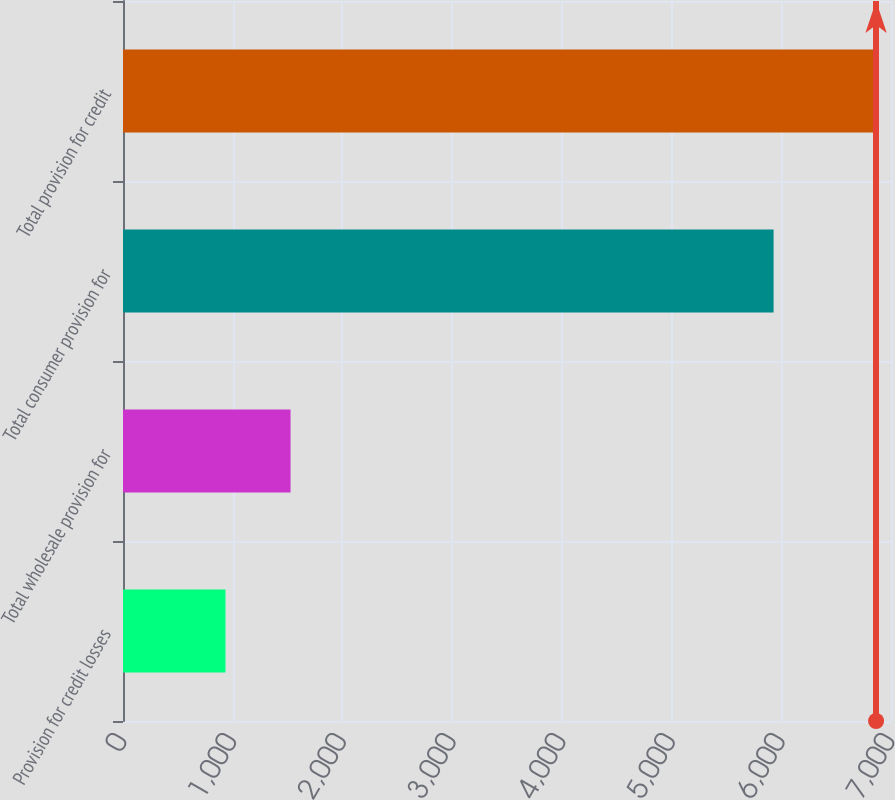Convert chart. <chart><loc_0><loc_0><loc_500><loc_500><bar_chart><fcel>Provision for credit losses<fcel>Total wholesale provision for<fcel>Total consumer provision for<fcel>Total provision for credit<nl><fcel>934<fcel>1527<fcel>5930<fcel>6864<nl></chart> 